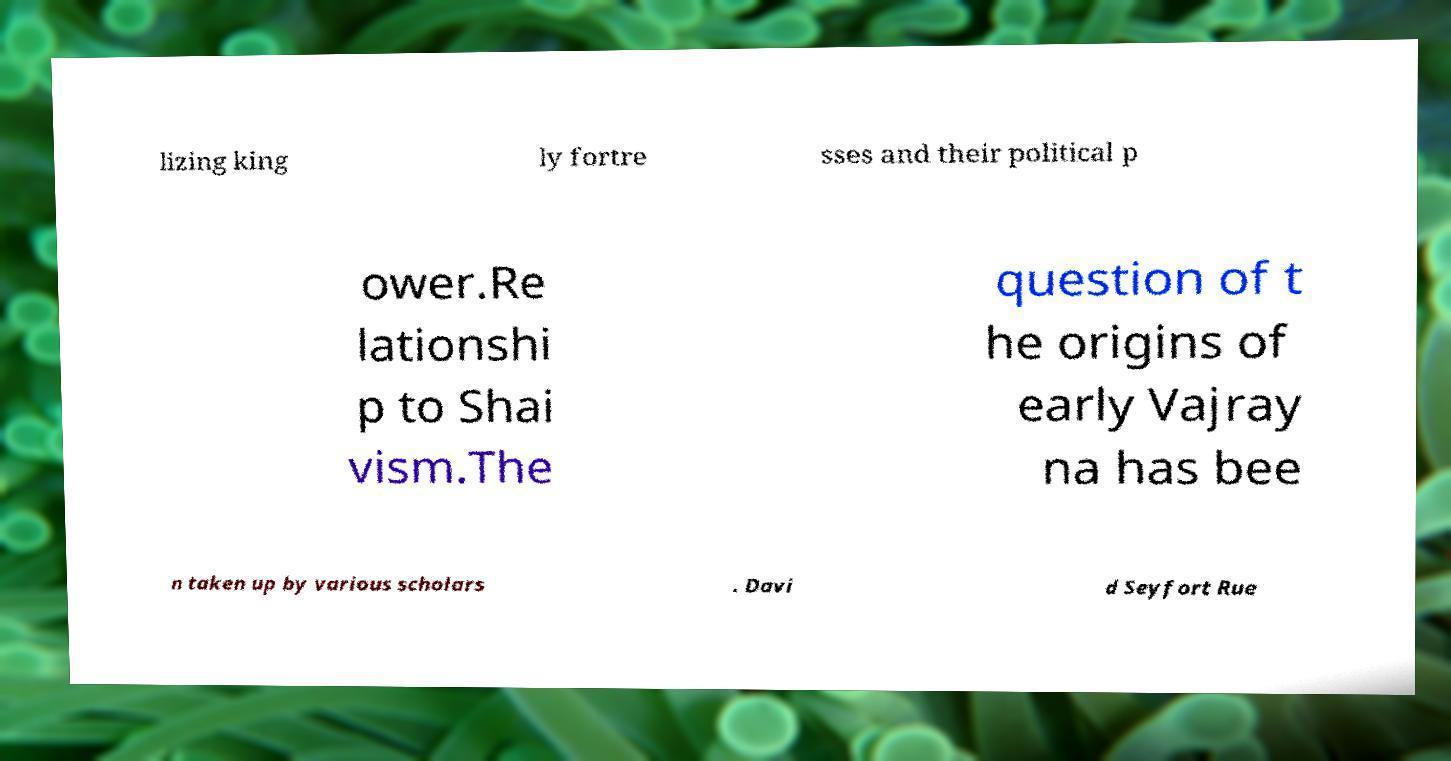Could you assist in decoding the text presented in this image and type it out clearly? lizing king ly fortre sses and their political p ower.Re lationshi p to Shai vism.The question of t he origins of early Vajray na has bee n taken up by various scholars . Davi d Seyfort Rue 